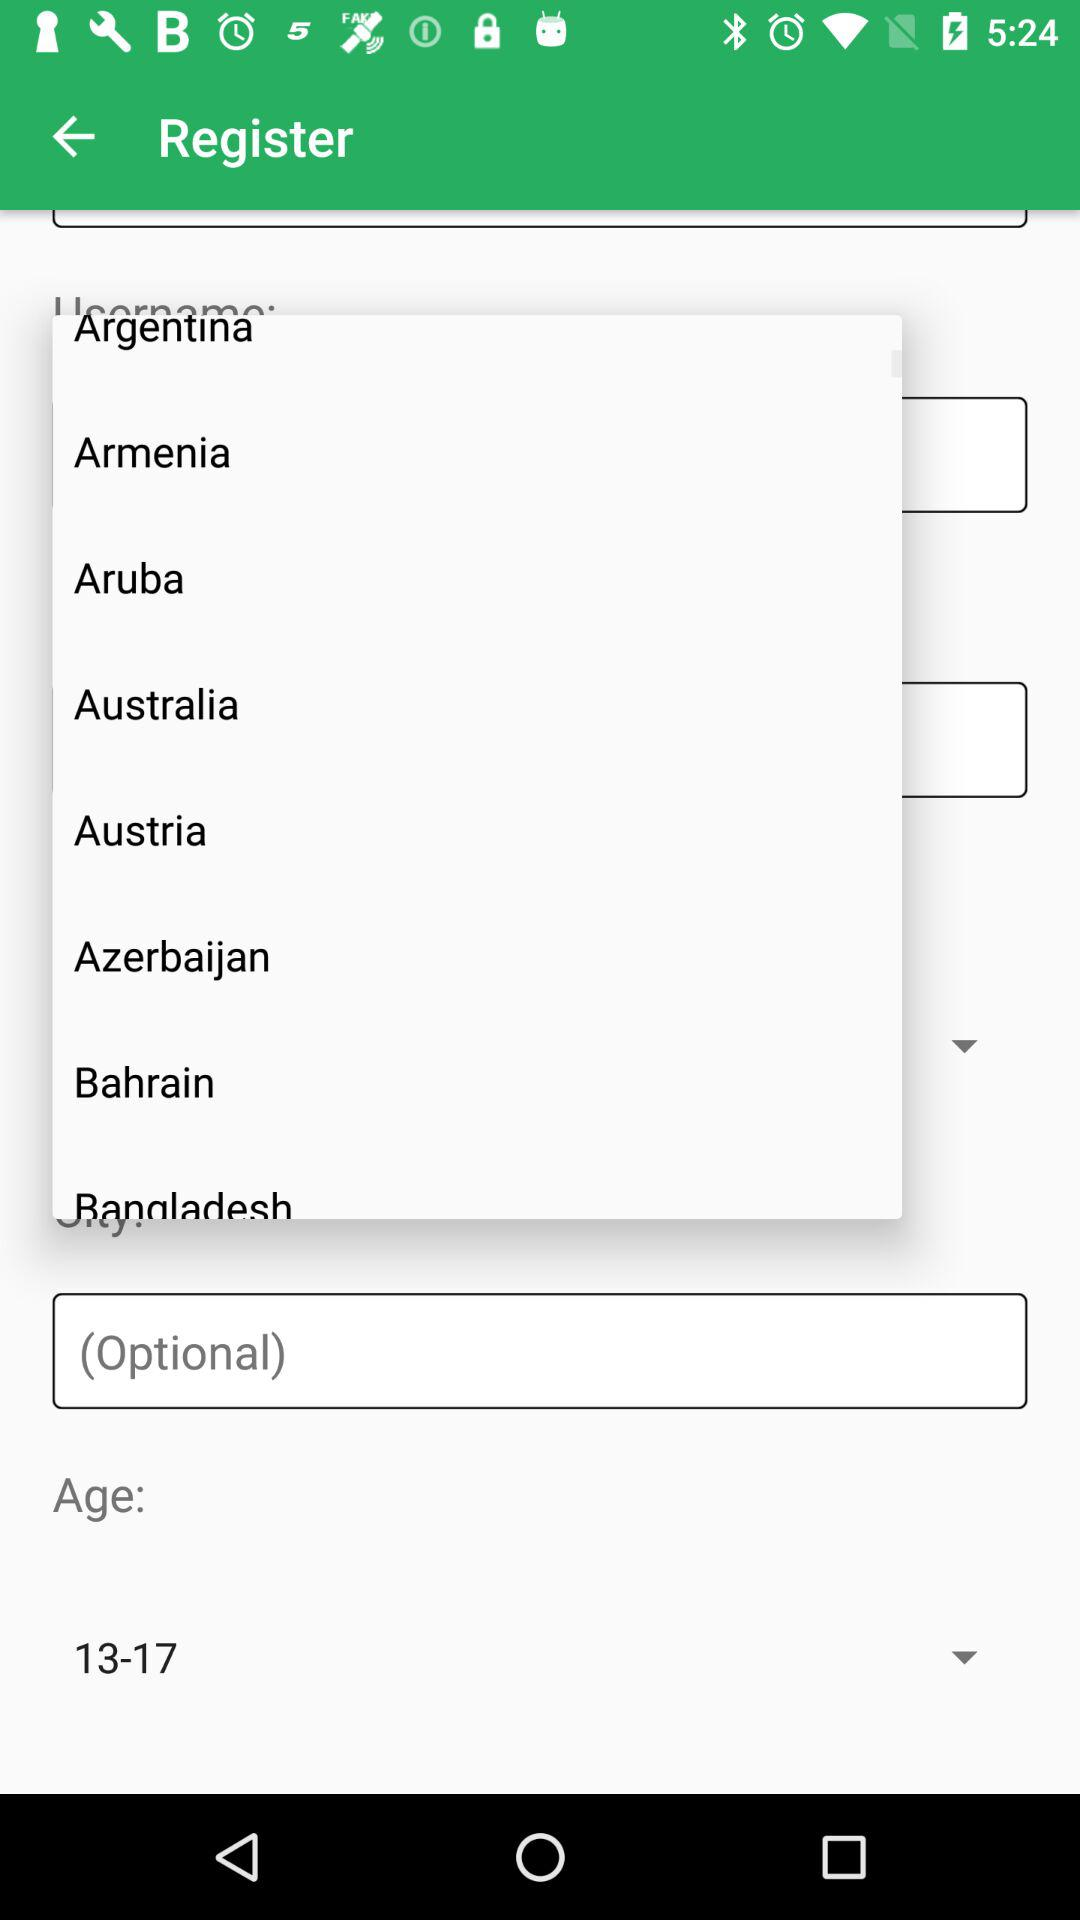Which age group is given here? The given age group is 13 to 17. 